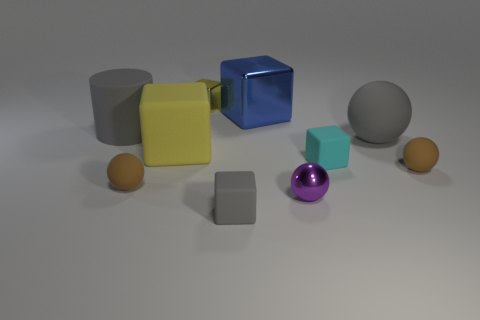If these objects were part of a still life painting, what might the artist be trying to convey? An artist may be using these geometric shapes to convey a sense of order and balance, contrasting with the seemingly random placement to create a narrative about structure and chaos in life. 